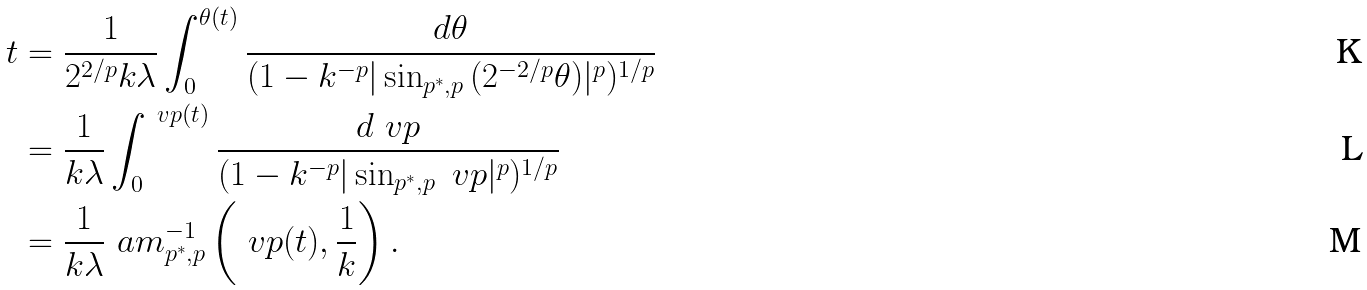Convert formula to latex. <formula><loc_0><loc_0><loc_500><loc_500>t & = \frac { 1 } { 2 ^ { 2 / p } k \lambda } \int _ { 0 } ^ { \theta ( t ) } \frac { d \theta } { ( 1 - k ^ { - p } | \sin _ { p ^ { * } , p } { ( 2 ^ { - 2 / p } \theta ) } | ^ { p } ) ^ { 1 / p } } \\ & = \frac { 1 } { k \lambda } \int _ { 0 } ^ { \ v p ( t ) } \frac { d \ v p } { ( 1 - k ^ { - p } | \sin _ { p ^ { * } , p } { \ v p } | ^ { p } ) ^ { 1 / p } } \\ & = \frac { 1 } { k \lambda } \ a m _ { p ^ { * } , p } ^ { - 1 } \left ( \ v p ( t ) , \frac { 1 } { k } \right ) .</formula> 